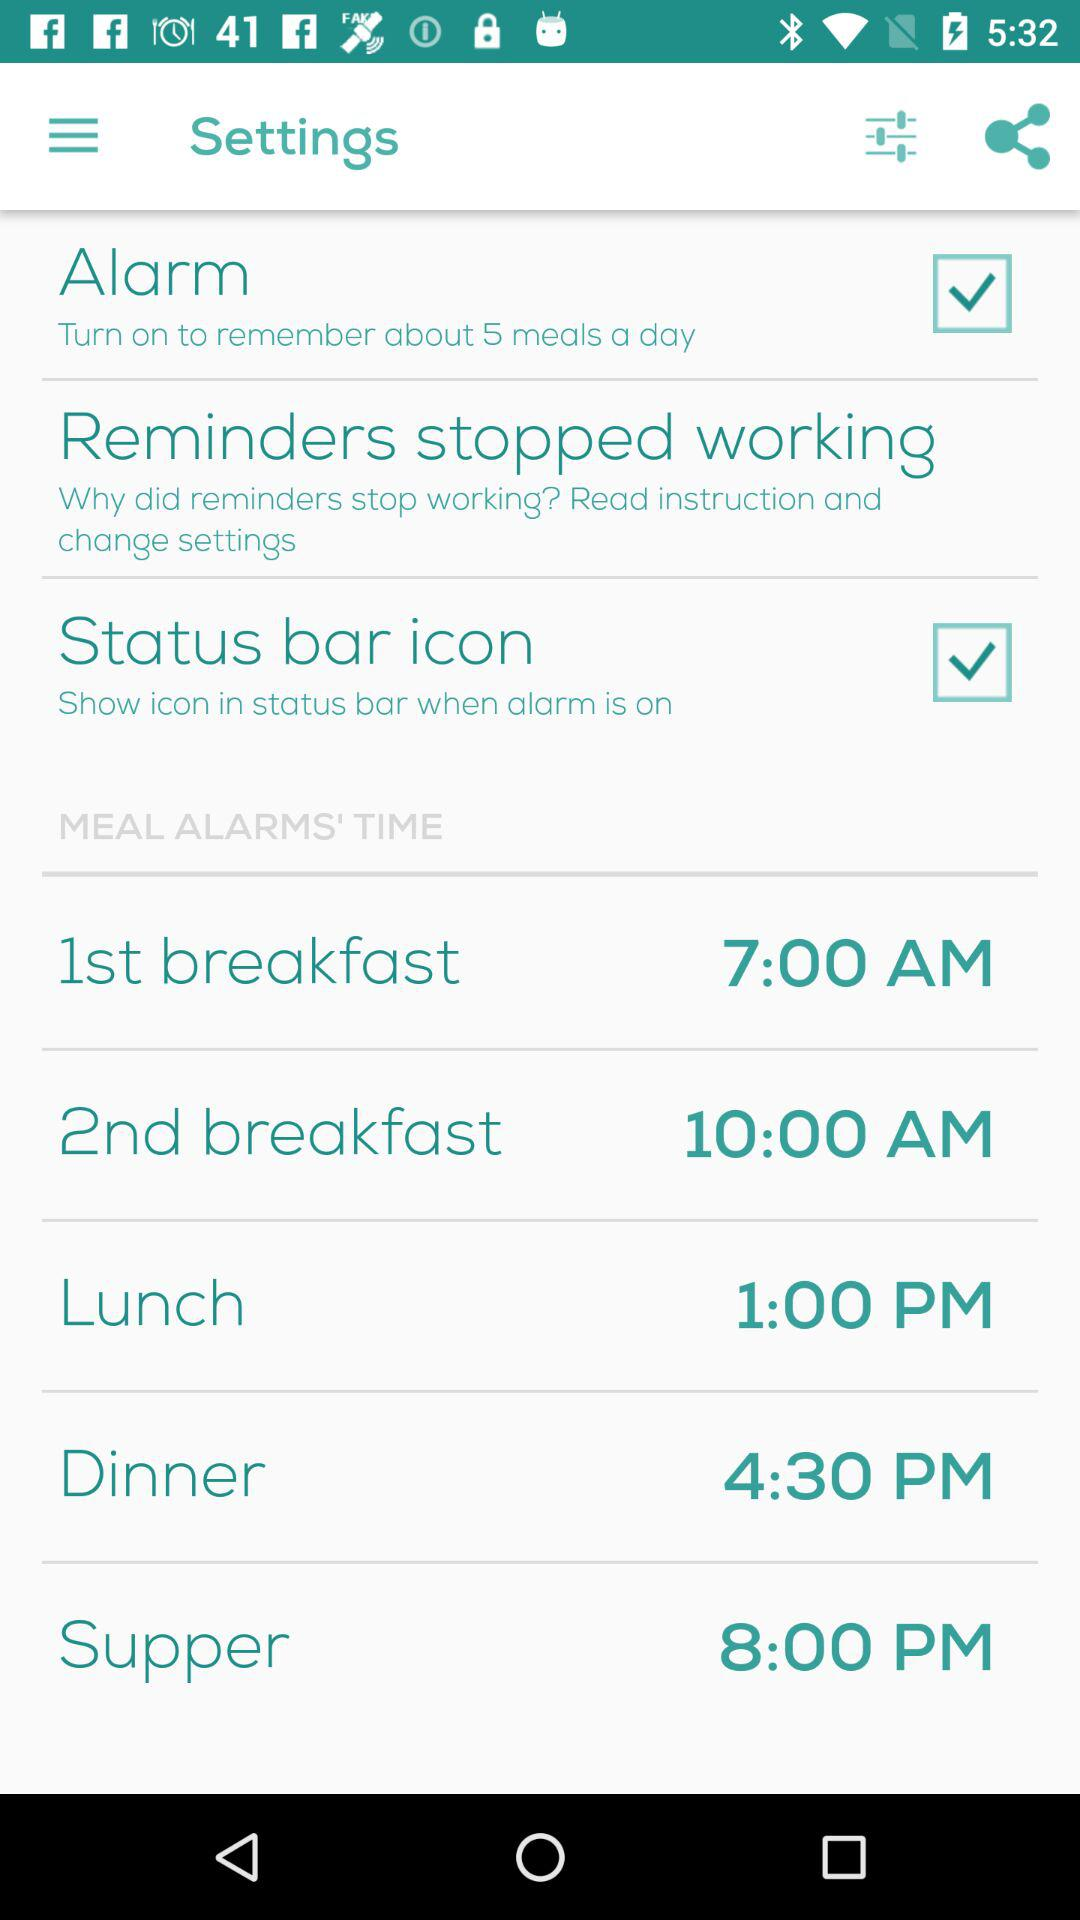What is the time for dinner? The time for dinner is 4:30 p.m. 